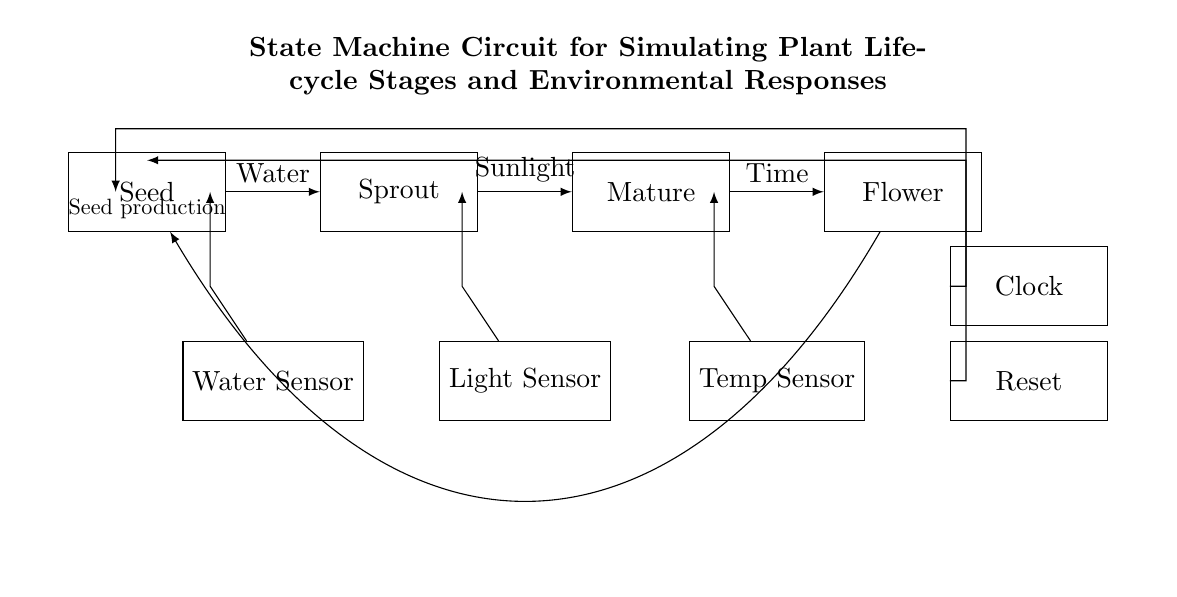What are the stages of the plant lifecycle represented in the circuit? The circuit shows four stages: Seed, Sprout, Mature, and Flower. These are indicated in labeled rectangles of the diagram.
Answer: Seed, Sprout, Mature, Flower What triggers the transition from 'Seed' to 'Sprout'? The transition is triggered by water, as indicated by the arrow pointing from the 'Seed' to 'Sprout' with the label 'Water'.
Answer: Water How many sensors are present in the circuit? There are three sensors: Water Sensor, Light Sensor, and Temp Sensor, as shown in separate rectangles below the plant states.
Answer: Three What does the 'Clock' component do in this circuit? The Clock component is used to provide timing signals to the state machine, indicated by its connection to the state stages, allowing for synchronized transitions.
Answer: Provides timing signals Which state requires 'Sunlight' to progress? The transition from 'Sprout' to 'Mature' requires Sunlight, as shown by the label on the arrow between those two states.
Answer: Sunlight What is the purpose of the 'Seed production' transition in this circuit? The 'Seed production' transition indicates the lifecycle return process that leads back to the 'Seed' state from the 'Flower' state, representing reproduction.
Answer: Reproduction 